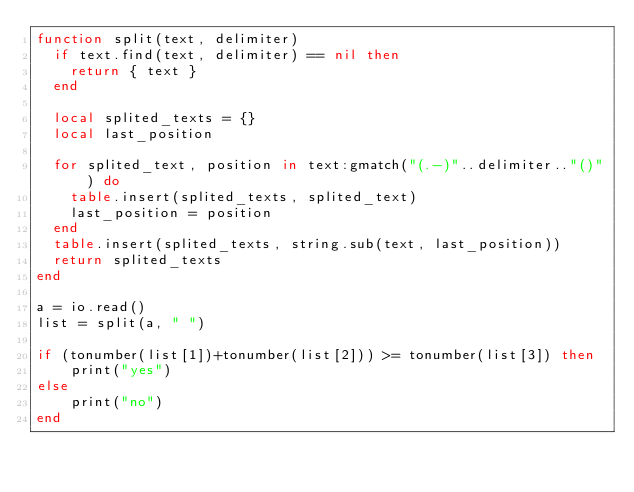Convert code to text. <code><loc_0><loc_0><loc_500><loc_500><_Lua_>function split(text, delimiter)
  if text.find(text, delimiter) == nil then
    return { text }
  end 

  local splited_texts = {}
  local last_position

  for splited_text, position in text:gmatch("(.-)"..delimiter.."()") do
    table.insert(splited_texts, splited_text)
    last_position = position
  end 
  table.insert(splited_texts, string.sub(text, last_position))
  return splited_texts
end

a = io.read()
list = split(a, " ")

if (tonumber(list[1])+tonumber(list[2])) >= tonumber(list[3]) then
    print("yes")
else
    print("no")
end
</code> 